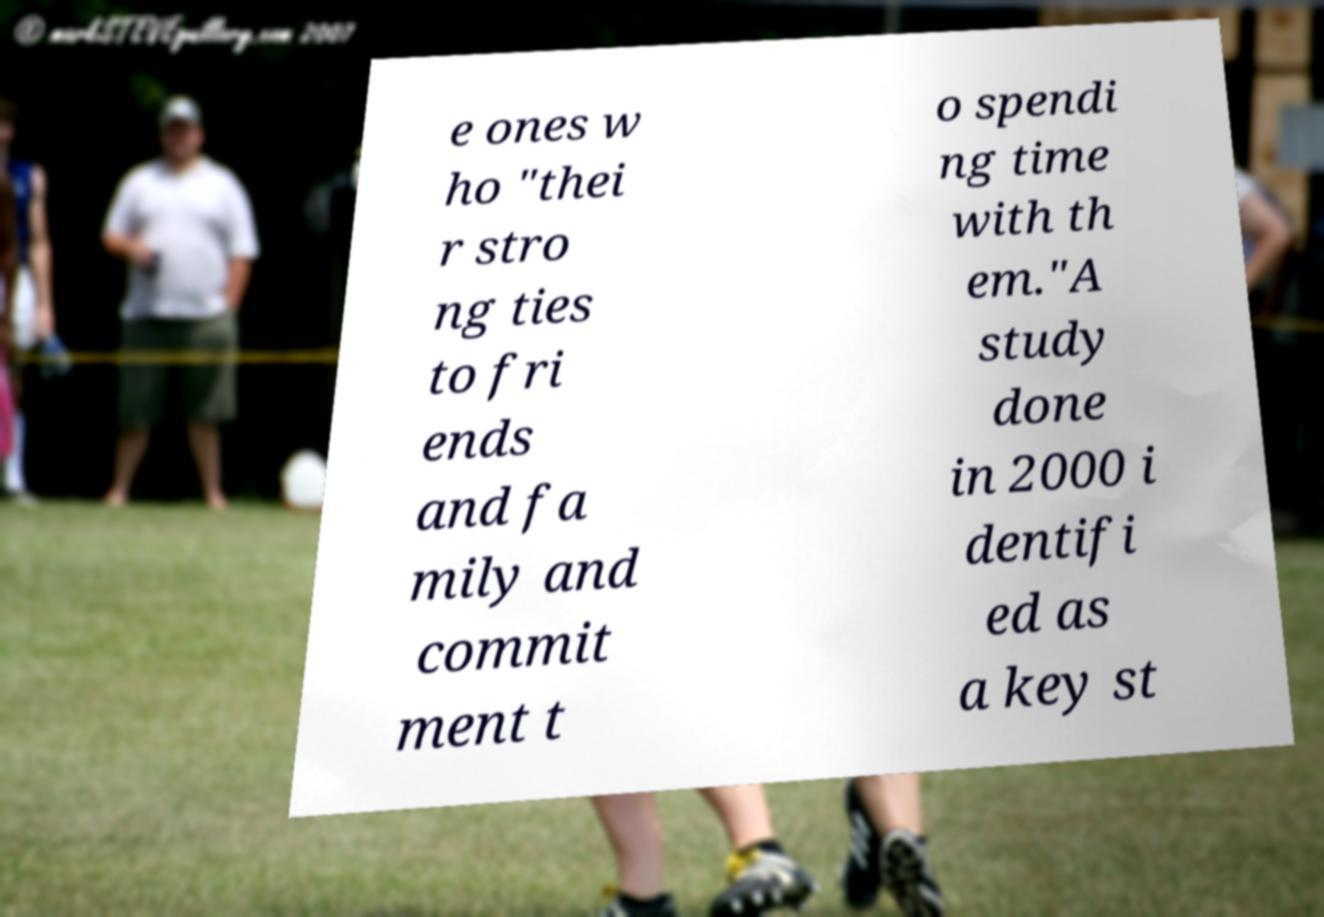Can you accurately transcribe the text from the provided image for me? e ones w ho "thei r stro ng ties to fri ends and fa mily and commit ment t o spendi ng time with th em."A study done in 2000 i dentifi ed as a key st 